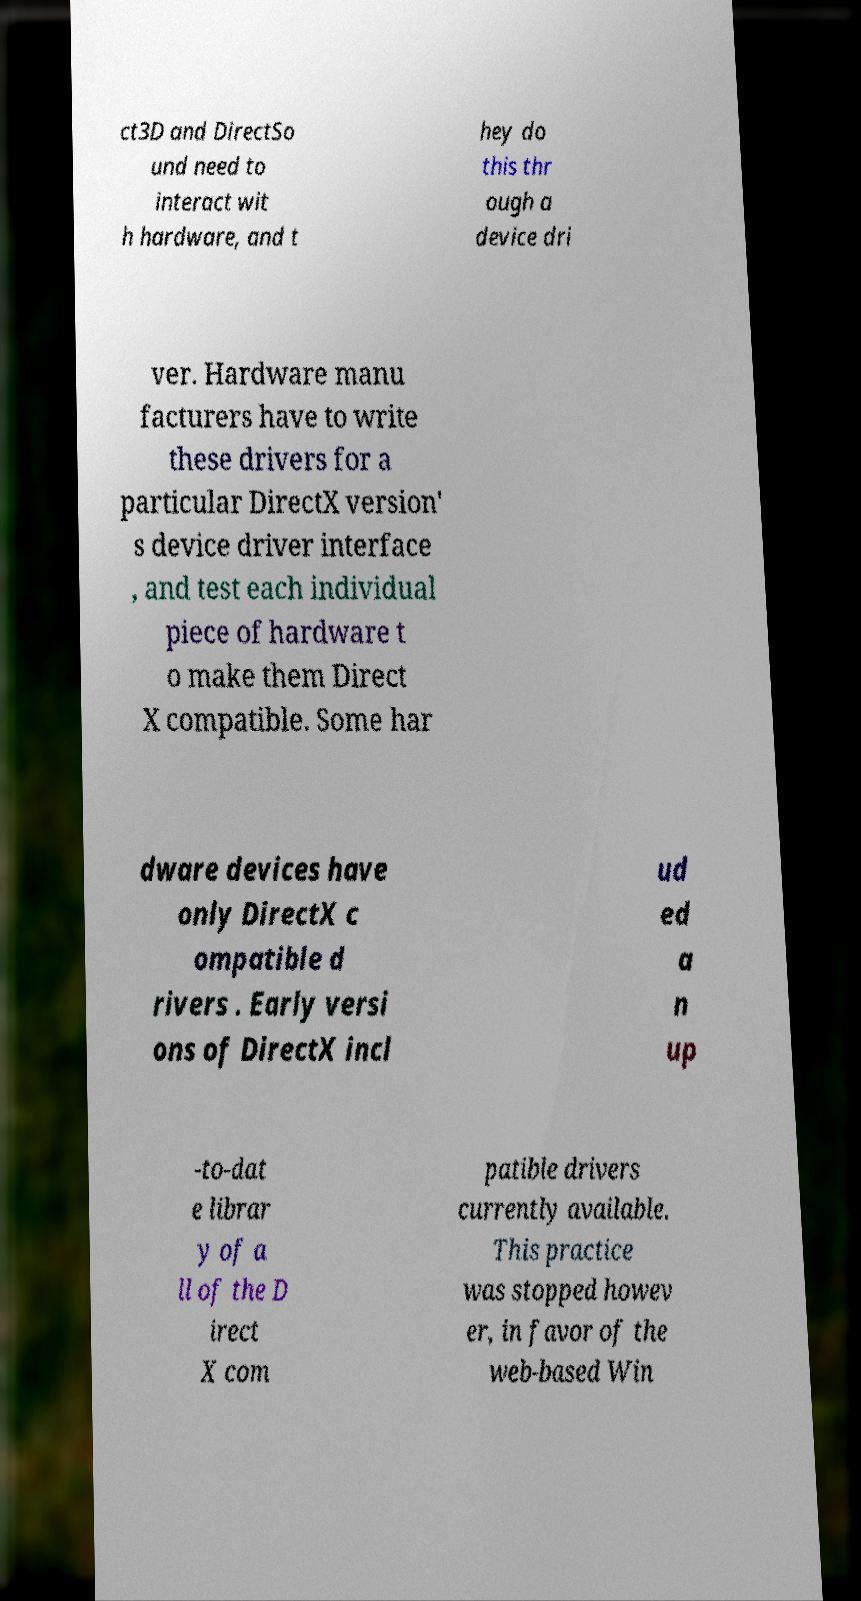For documentation purposes, I need the text within this image transcribed. Could you provide that? ct3D and DirectSo und need to interact wit h hardware, and t hey do this thr ough a device dri ver. Hardware manu facturers have to write these drivers for a particular DirectX version' s device driver interface , and test each individual piece of hardware t o make them Direct X compatible. Some har dware devices have only DirectX c ompatible d rivers . Early versi ons of DirectX incl ud ed a n up -to-dat e librar y of a ll of the D irect X com patible drivers currently available. This practice was stopped howev er, in favor of the web-based Win 